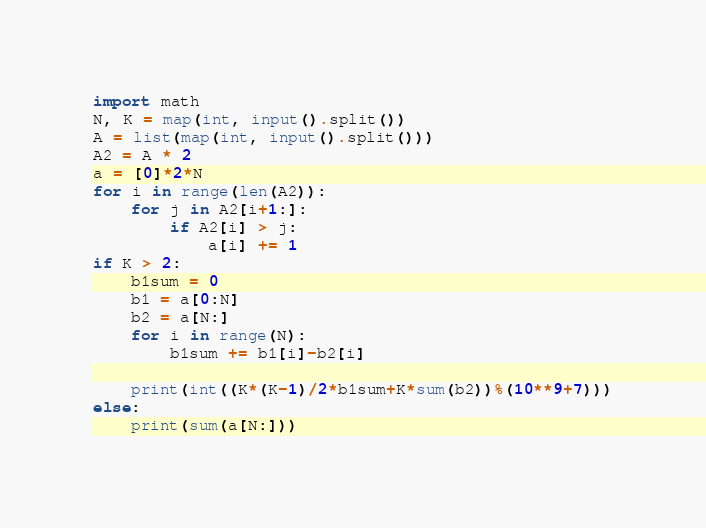<code> <loc_0><loc_0><loc_500><loc_500><_Python_>import math
N, K = map(int, input().split())
A = list(map(int, input().split()))
A2 = A * 2
a = [0]*2*N
for i in range(len(A2)):
    for j in A2[i+1:]:
        if A2[i] > j:
            a[i] += 1
if K > 2:
    b1sum = 0
    b1 = a[0:N]
    b2 = a[N:]
    for i in range(N):
        b1sum += b1[i]-b2[i]

    print(int((K*(K-1)/2*b1sum+K*sum(b2))%(10**9+7)))
else:
    print(sum(a[N:]))
</code> 